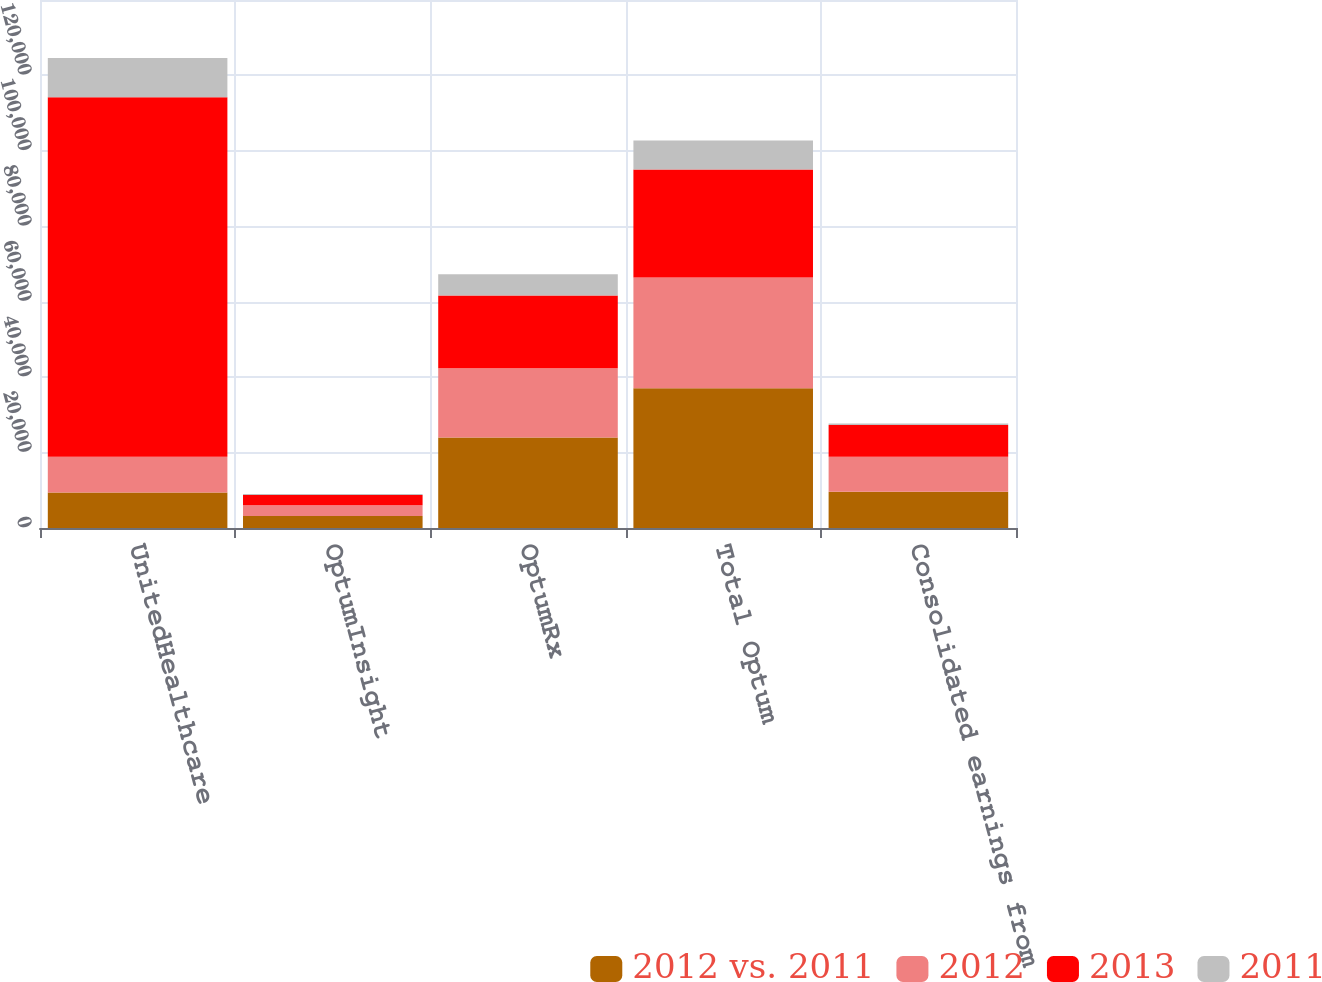<chart> <loc_0><loc_0><loc_500><loc_500><stacked_bar_chart><ecel><fcel>UnitedHealthcare<fcel>OptumInsight<fcel>OptumRx<fcel>Total Optum<fcel>Consolidated earnings from<nl><fcel>2012 vs. 2011<fcel>9438.5<fcel>3174<fcel>24006<fcel>37035<fcel>9623<nl><fcel>2012<fcel>9438.5<fcel>2882<fcel>18359<fcel>29388<fcel>9254<nl><fcel>2013<fcel>95336<fcel>2671<fcel>19278<fcel>28653<fcel>8464<nl><fcel>2011<fcel>10410<fcel>292<fcel>5647<fcel>7647<fcel>369<nl></chart> 